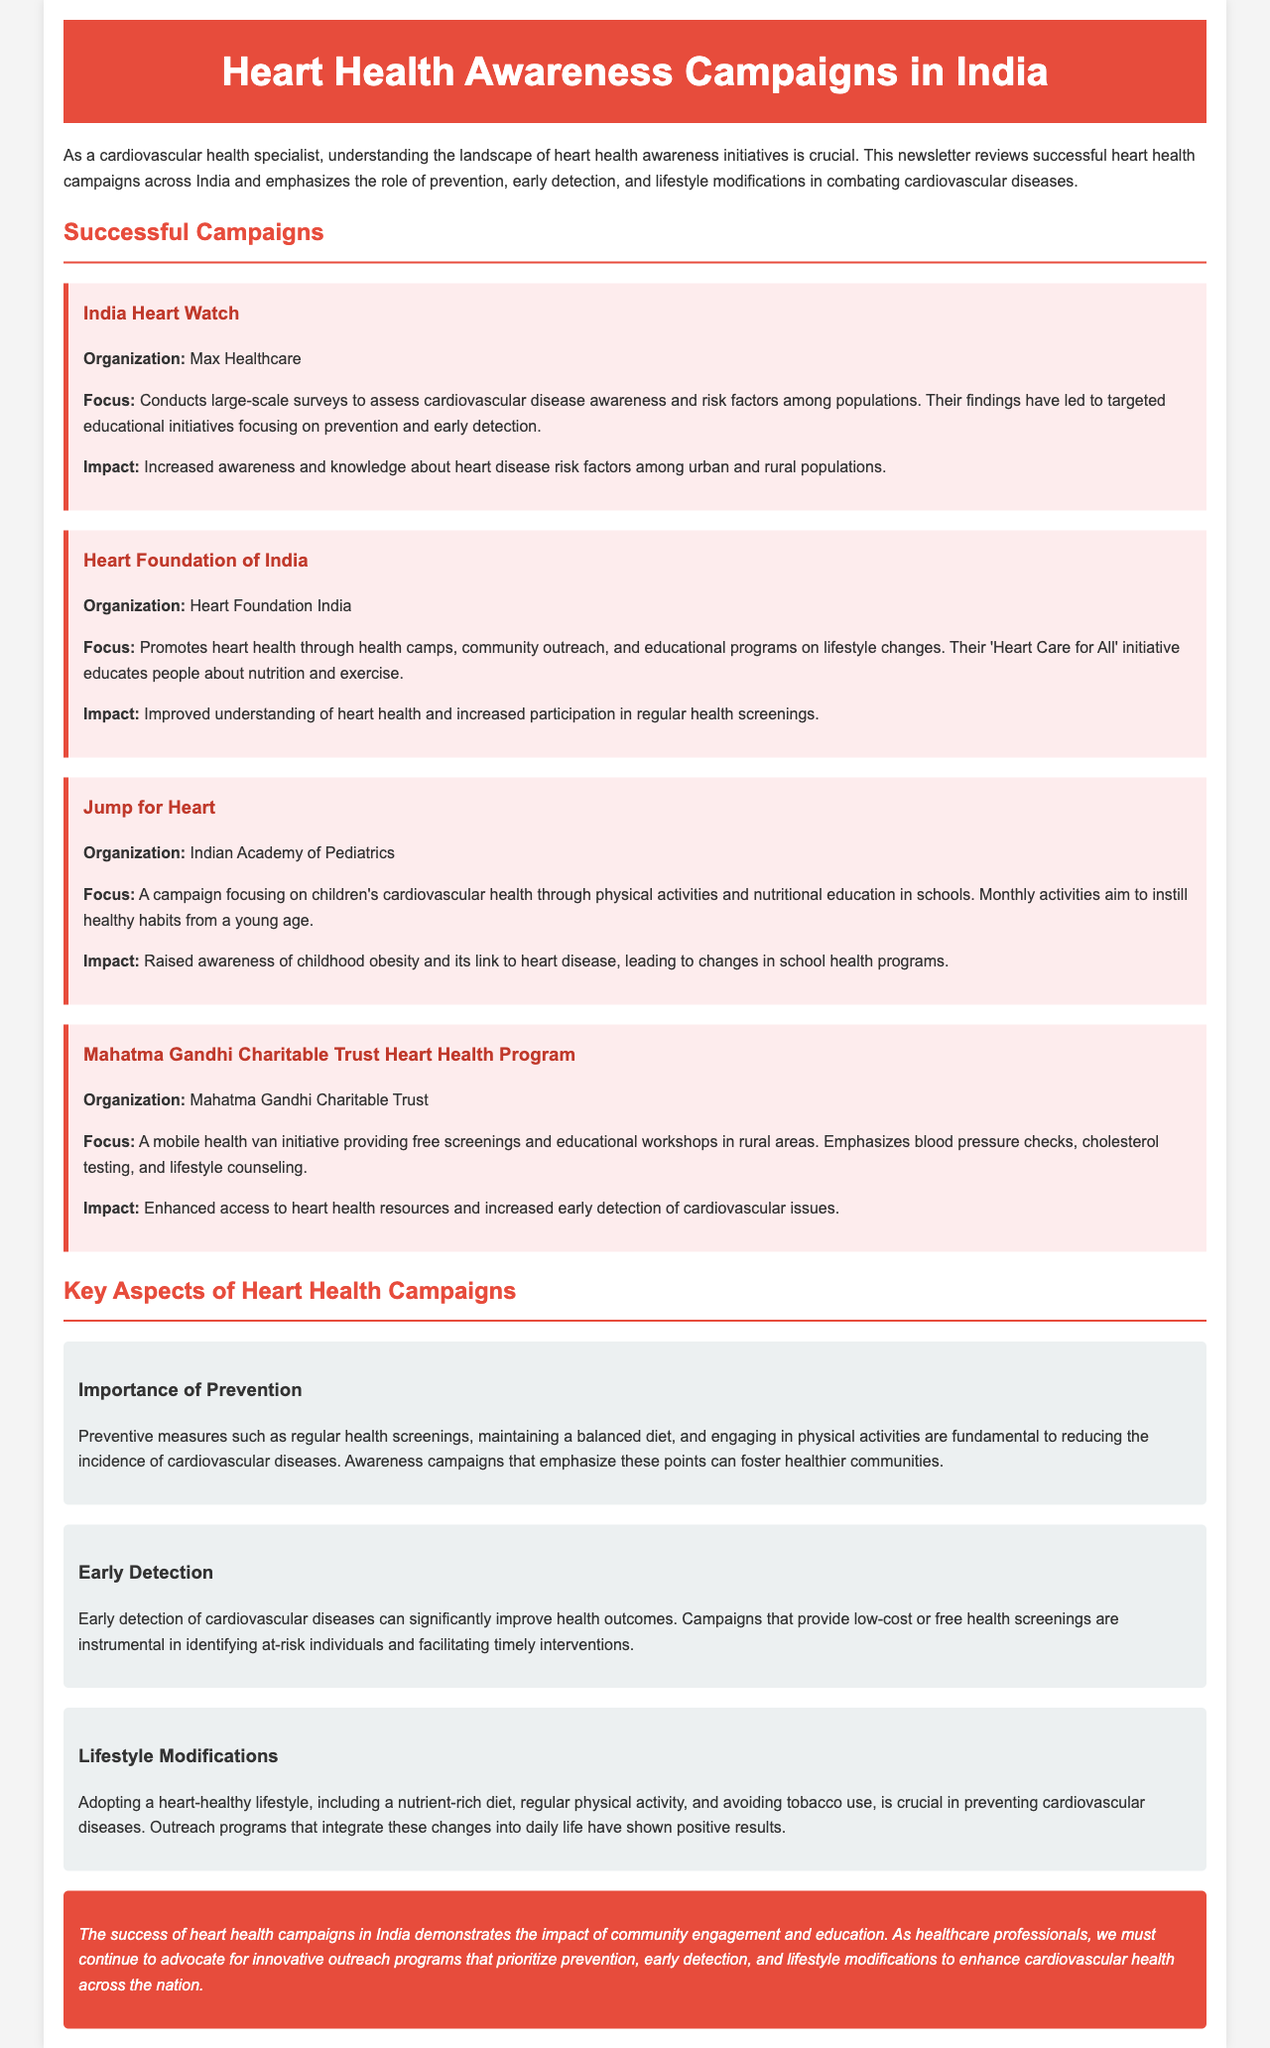What is the title of the newsletter? The title of the newsletter is mentioned in the header section of the document.
Answer: Heart Health Awareness Campaigns in India Which organization conducts the India Heart Watch campaign? The document provides the name of the organization responsible for this campaign.
Answer: Max Healthcare What is the focus of the Heart Foundation of India campaign? The document describes the main focus of this campaign in a clear statement.
Answer: Health camps, community outreach, and educational programs on lifestyle changes What initiative educates about children's cardiovascular health? The document lists several campaigns, one of which is specifically geared towards children's health.
Answer: Jump for Heart What is a key aspect of cardiovascular health campaigns emphasized in the document? The document outlines several important topics related to heart health initiatives, one of which is prevention.
Answer: Prevention How does the Mahatma Gandhi Charitable Trust Heart Health Program enhance access? The document explains how this program provides specific health services.
Answer: Mobile health van initiative providing free screenings What lifestyle changes does the newsletter emphasize for heart health? The document mentions specific lifestyle modifications as essential for preventing cardiovascular diseases.
Answer: Nutrient-rich diet and regular physical activity What is a significant impact of the Jump for Heart campaign? The document specifically highlights the outcome of this particular initiative regarding awareness.
Answer: Raised awareness of childhood obesity and its link to heart disease 